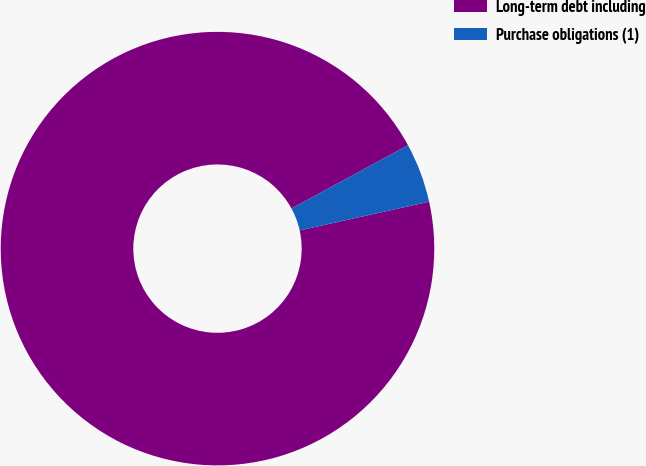Convert chart. <chart><loc_0><loc_0><loc_500><loc_500><pie_chart><fcel>Long-term debt including<fcel>Purchase obligations (1)<nl><fcel>95.56%<fcel>4.44%<nl></chart> 